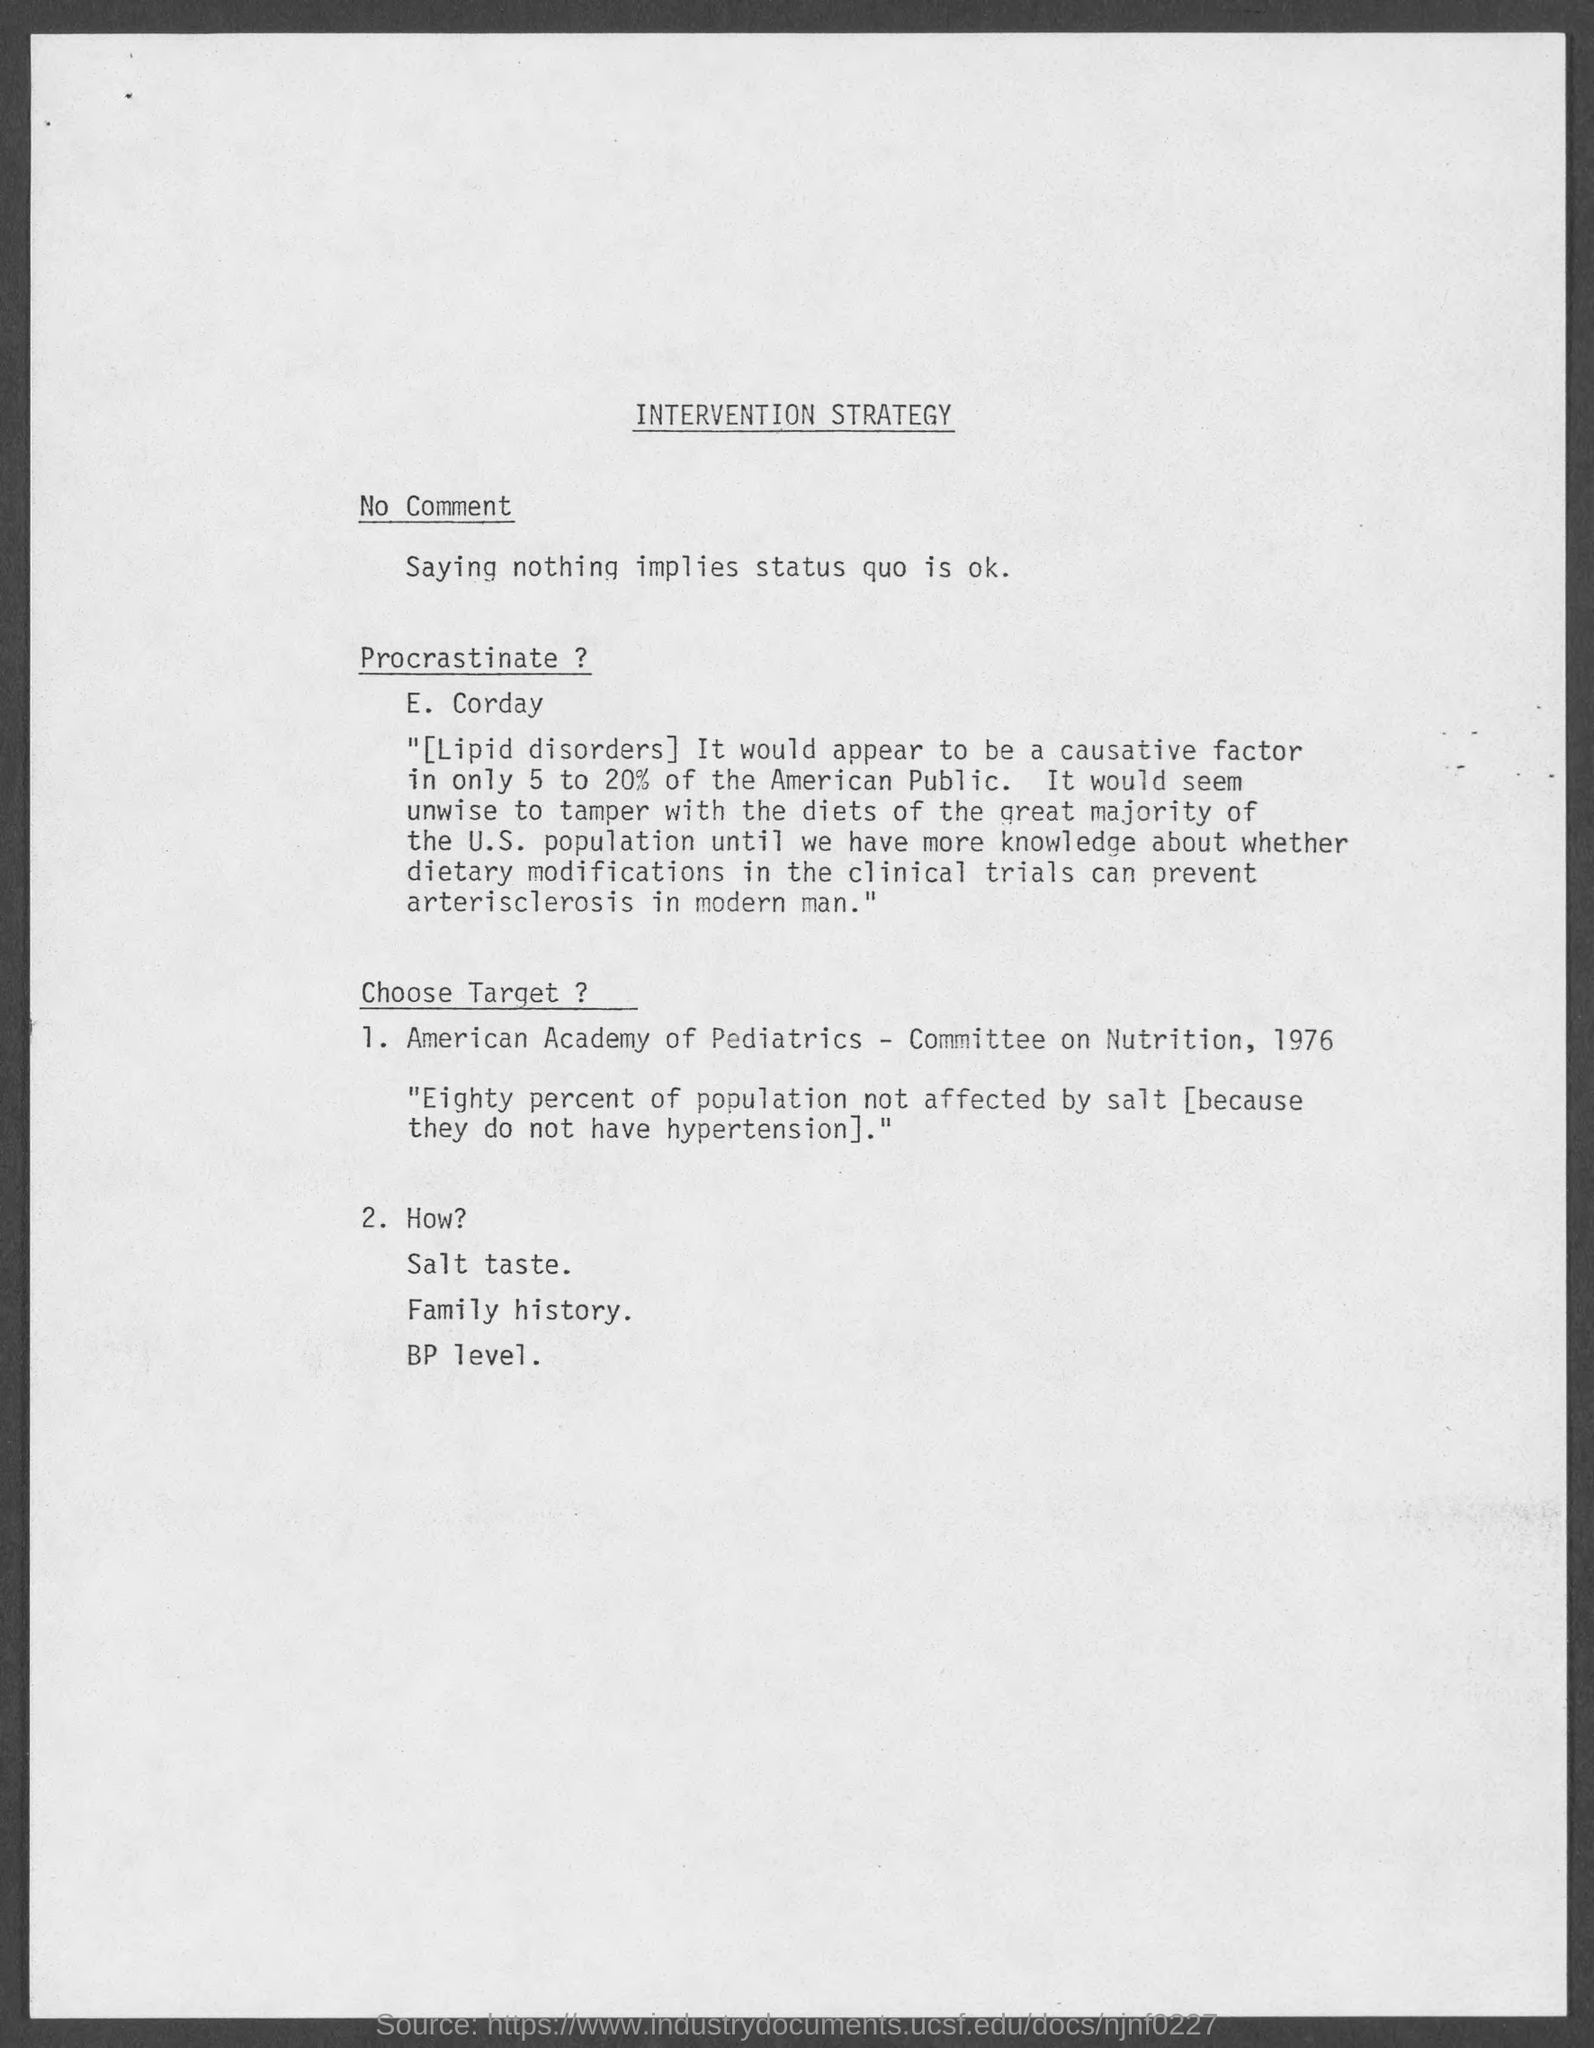What is the heading at top of the page ?
Your answer should be compact. Intervention Strategy. 